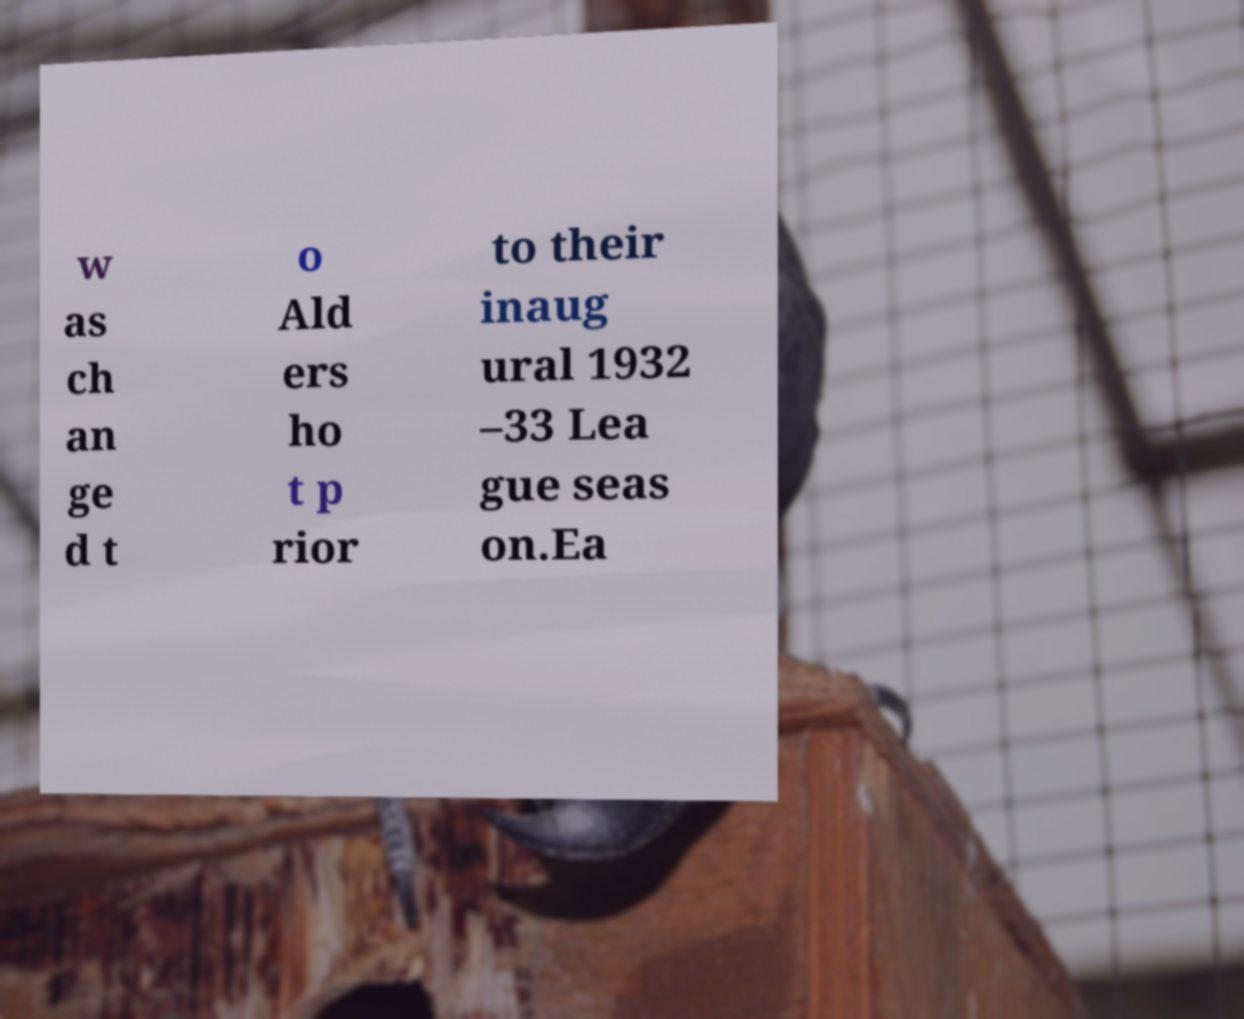Can you read and provide the text displayed in the image?This photo seems to have some interesting text. Can you extract and type it out for me? w as ch an ge d t o Ald ers ho t p rior to their inaug ural 1932 –33 Lea gue seas on.Ea 